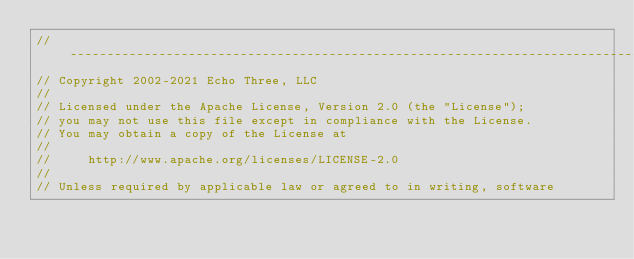<code> <loc_0><loc_0><loc_500><loc_500><_Java_>// --------------------------------------------------------------------------------
// Copyright 2002-2021 Echo Three, LLC
//
// Licensed under the Apache License, Version 2.0 (the "License");
// you may not use this file except in compliance with the License.
// You may obtain a copy of the License at
//
//     http://www.apache.org/licenses/LICENSE-2.0
//
// Unless required by applicable law or agreed to in writing, software</code> 